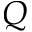Convert formula to latex. <formula><loc_0><loc_0><loc_500><loc_500>Q</formula> 